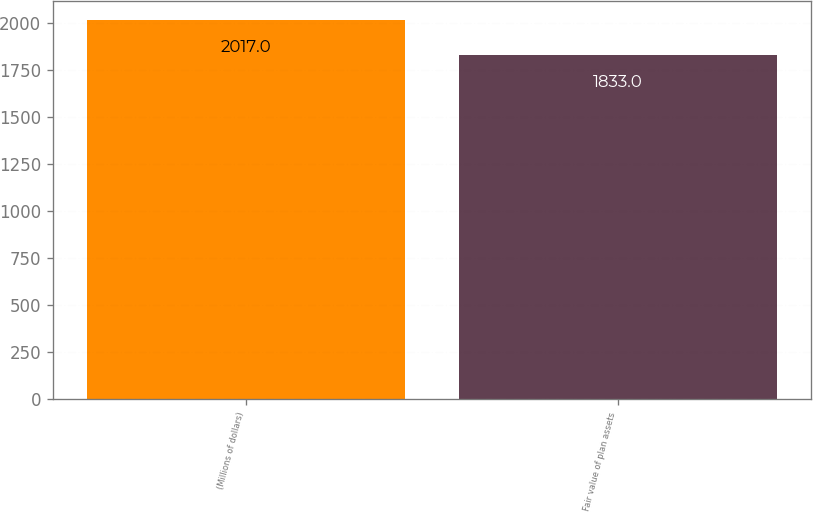Convert chart. <chart><loc_0><loc_0><loc_500><loc_500><bar_chart><fcel>(Millions of dollars)<fcel>Fair value of plan assets<nl><fcel>2017<fcel>1833<nl></chart> 